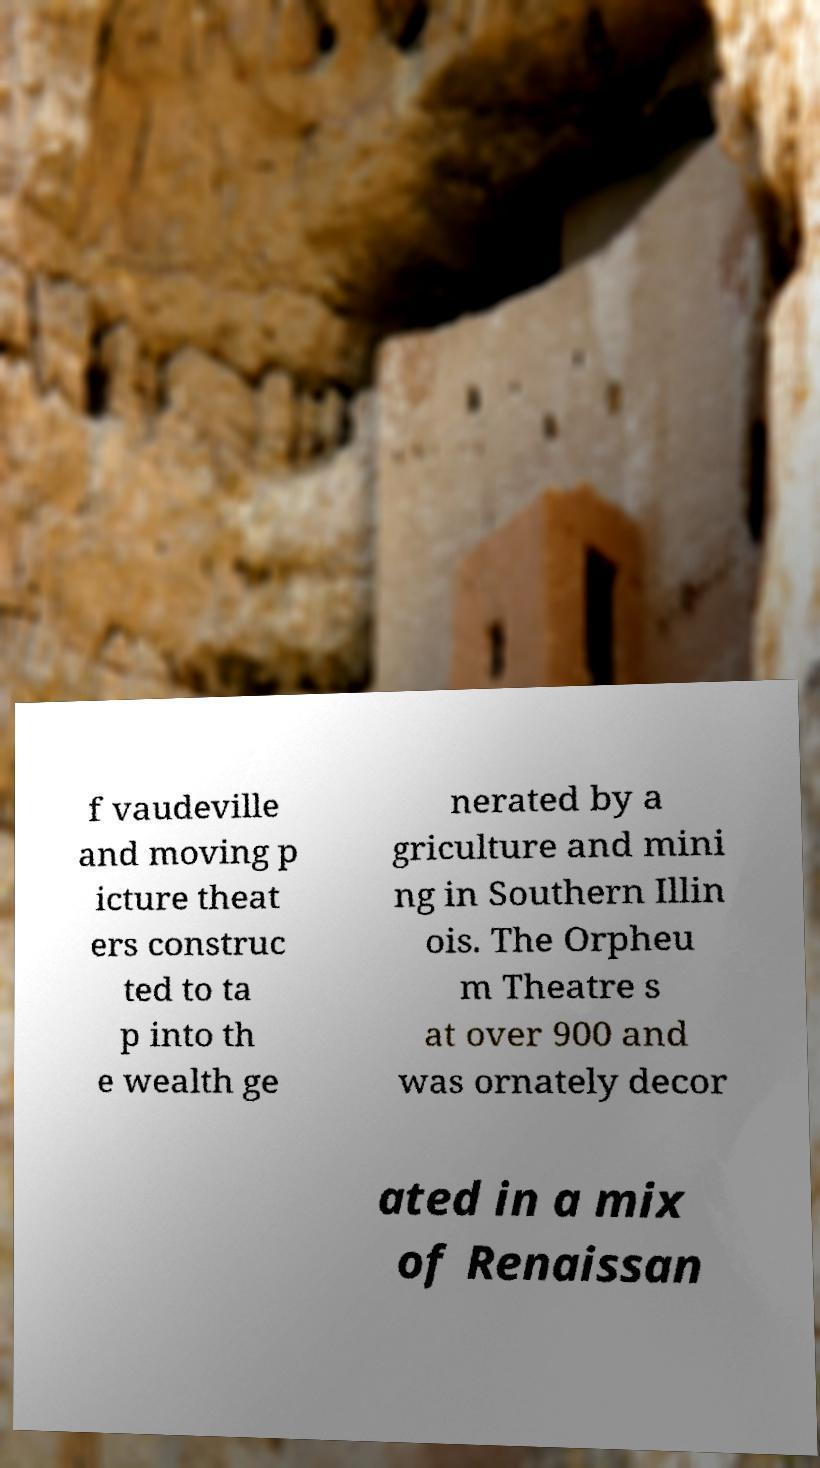I need the written content from this picture converted into text. Can you do that? f vaudeville and moving p icture theat ers construc ted to ta p into th e wealth ge nerated by a griculture and mini ng in Southern Illin ois. The Orpheu m Theatre s at over 900 and was ornately decor ated in a mix of Renaissan 